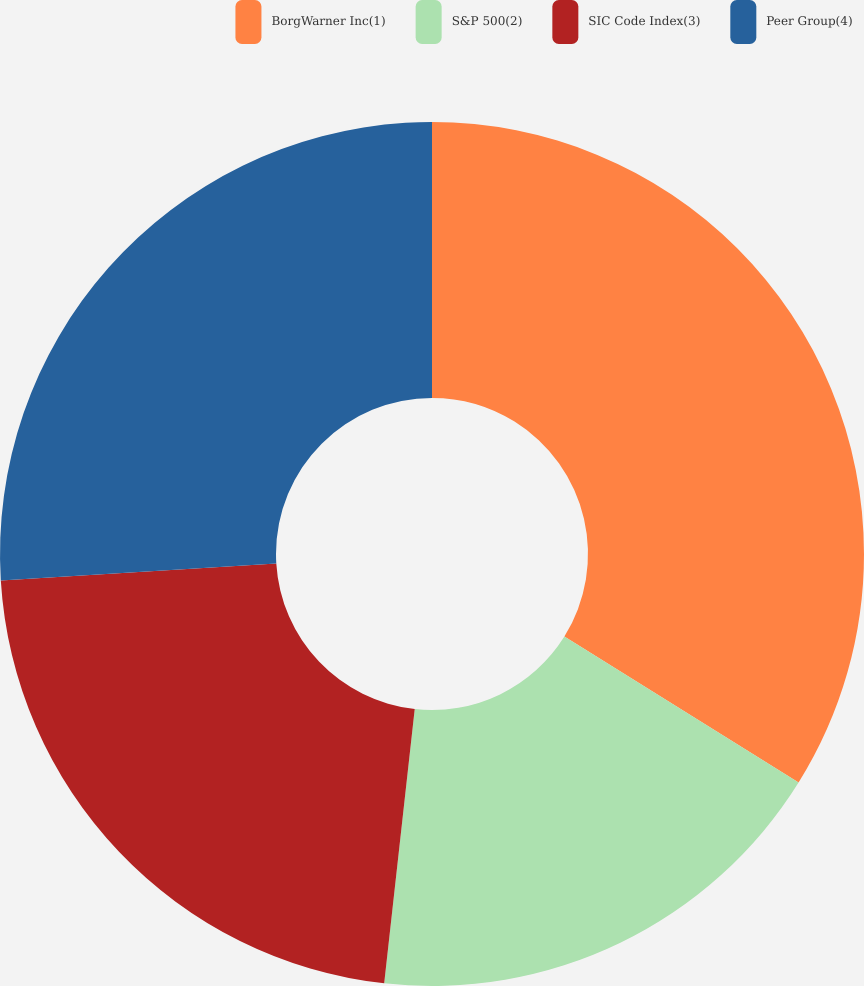Convert chart to OTSL. <chart><loc_0><loc_0><loc_500><loc_500><pie_chart><fcel>BorgWarner Inc(1)<fcel>S&P 500(2)<fcel>SIC Code Index(3)<fcel>Peer Group(4)<nl><fcel>33.87%<fcel>17.89%<fcel>22.26%<fcel>25.97%<nl></chart> 